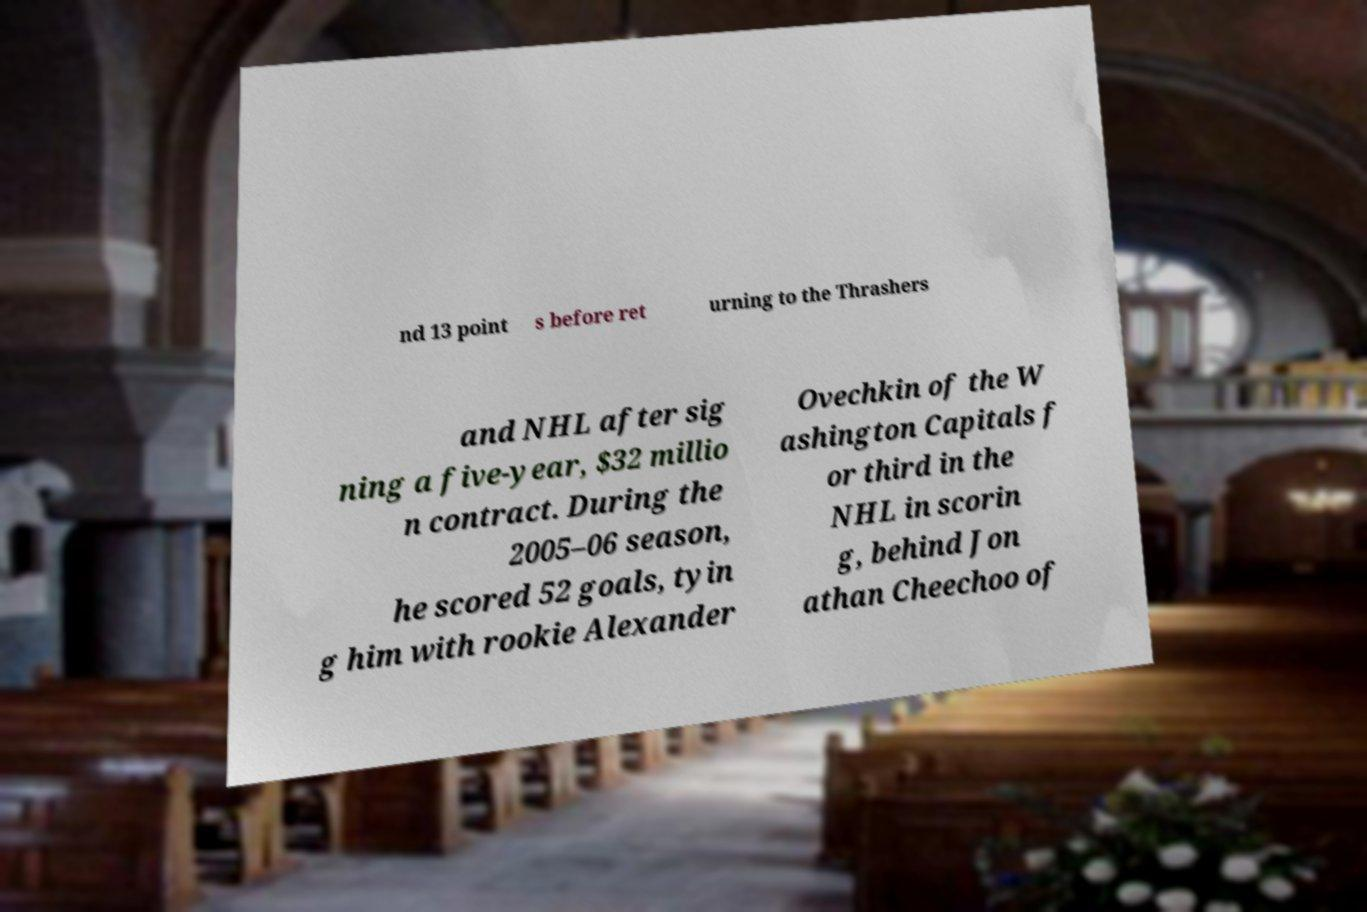I need the written content from this picture converted into text. Can you do that? nd 13 point s before ret urning to the Thrashers and NHL after sig ning a five-year, $32 millio n contract. During the 2005–06 season, he scored 52 goals, tyin g him with rookie Alexander Ovechkin of the W ashington Capitals f or third in the NHL in scorin g, behind Jon athan Cheechoo of 